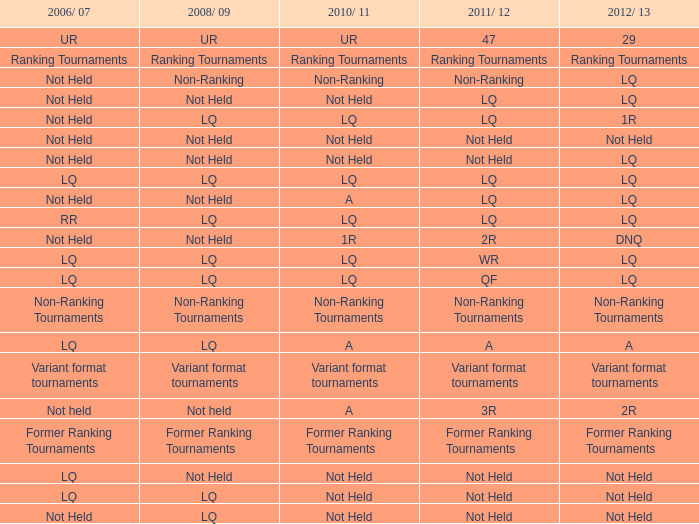What is 2006/07, when 2008/09 is LQ, and when 2010/11 is Not Held? LQ, Not Held. Write the full table. {'header': ['2006/ 07', '2008/ 09', '2010/ 11', '2011/ 12', '2012/ 13'], 'rows': [['UR', 'UR', 'UR', '47', '29'], ['Ranking Tournaments', 'Ranking Tournaments', 'Ranking Tournaments', 'Ranking Tournaments', 'Ranking Tournaments'], ['Not Held', 'Non-Ranking', 'Non-Ranking', 'Non-Ranking', 'LQ'], ['Not Held', 'Not Held', 'Not Held', 'LQ', 'LQ'], ['Not Held', 'LQ', 'LQ', 'LQ', '1R'], ['Not Held', 'Not Held', 'Not Held', 'Not Held', 'Not Held'], ['Not Held', 'Not Held', 'Not Held', 'Not Held', 'LQ'], ['LQ', 'LQ', 'LQ', 'LQ', 'LQ'], ['Not Held', 'Not Held', 'A', 'LQ', 'LQ'], ['RR', 'LQ', 'LQ', 'LQ', 'LQ'], ['Not Held', 'Not Held', '1R', '2R', 'DNQ'], ['LQ', 'LQ', 'LQ', 'WR', 'LQ'], ['LQ', 'LQ', 'LQ', 'QF', 'LQ'], ['Non-Ranking Tournaments', 'Non-Ranking Tournaments', 'Non-Ranking Tournaments', 'Non-Ranking Tournaments', 'Non-Ranking Tournaments'], ['LQ', 'LQ', 'A', 'A', 'A'], ['Variant format tournaments', 'Variant format tournaments', 'Variant format tournaments', 'Variant format tournaments', 'Variant format tournaments'], ['Not held', 'Not held', 'A', '3R', '2R'], ['Former Ranking Tournaments', 'Former Ranking Tournaments', 'Former Ranking Tournaments', 'Former Ranking Tournaments', 'Former Ranking Tournaments'], ['LQ', 'Not Held', 'Not Held', 'Not Held', 'Not Held'], ['LQ', 'LQ', 'Not Held', 'Not Held', 'Not Held'], ['Not Held', 'LQ', 'Not Held', 'Not Held', 'Not Held']]} 